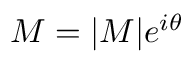Convert formula to latex. <formula><loc_0><loc_0><loc_500><loc_500>M = | M | e ^ { i \theta }</formula> 